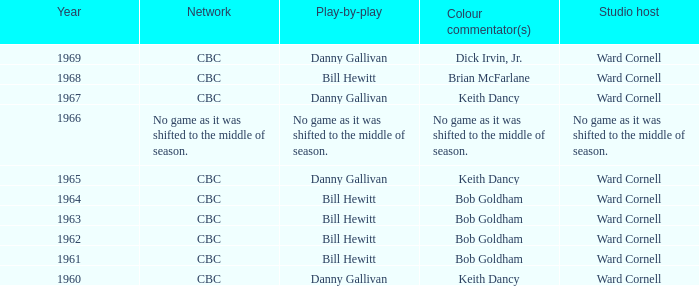Did the color commentators collaborate with bill hewitt on play-by-play duties? Brian McFarlane, Bob Goldham, Bob Goldham, Bob Goldham, Bob Goldham. Could you help me parse every detail presented in this table? {'header': ['Year', 'Network', 'Play-by-play', 'Colour commentator(s)', 'Studio host'], 'rows': [['1969', 'CBC', 'Danny Gallivan', 'Dick Irvin, Jr.', 'Ward Cornell'], ['1968', 'CBC', 'Bill Hewitt', 'Brian McFarlane', 'Ward Cornell'], ['1967', 'CBC', 'Danny Gallivan', 'Keith Dancy', 'Ward Cornell'], ['1966', 'No game as it was shifted to the middle of season.', 'No game as it was shifted to the middle of season.', 'No game as it was shifted to the middle of season.', 'No game as it was shifted to the middle of season.'], ['1965', 'CBC', 'Danny Gallivan', 'Keith Dancy', 'Ward Cornell'], ['1964', 'CBC', 'Bill Hewitt', 'Bob Goldham', 'Ward Cornell'], ['1963', 'CBC', 'Bill Hewitt', 'Bob Goldham', 'Ward Cornell'], ['1962', 'CBC', 'Bill Hewitt', 'Bob Goldham', 'Ward Cornell'], ['1961', 'CBC', 'Bill Hewitt', 'Bob Goldham', 'Ward Cornell'], ['1960', 'CBC', 'Danny Gallivan', 'Keith Dancy', 'Ward Cornell']]} 